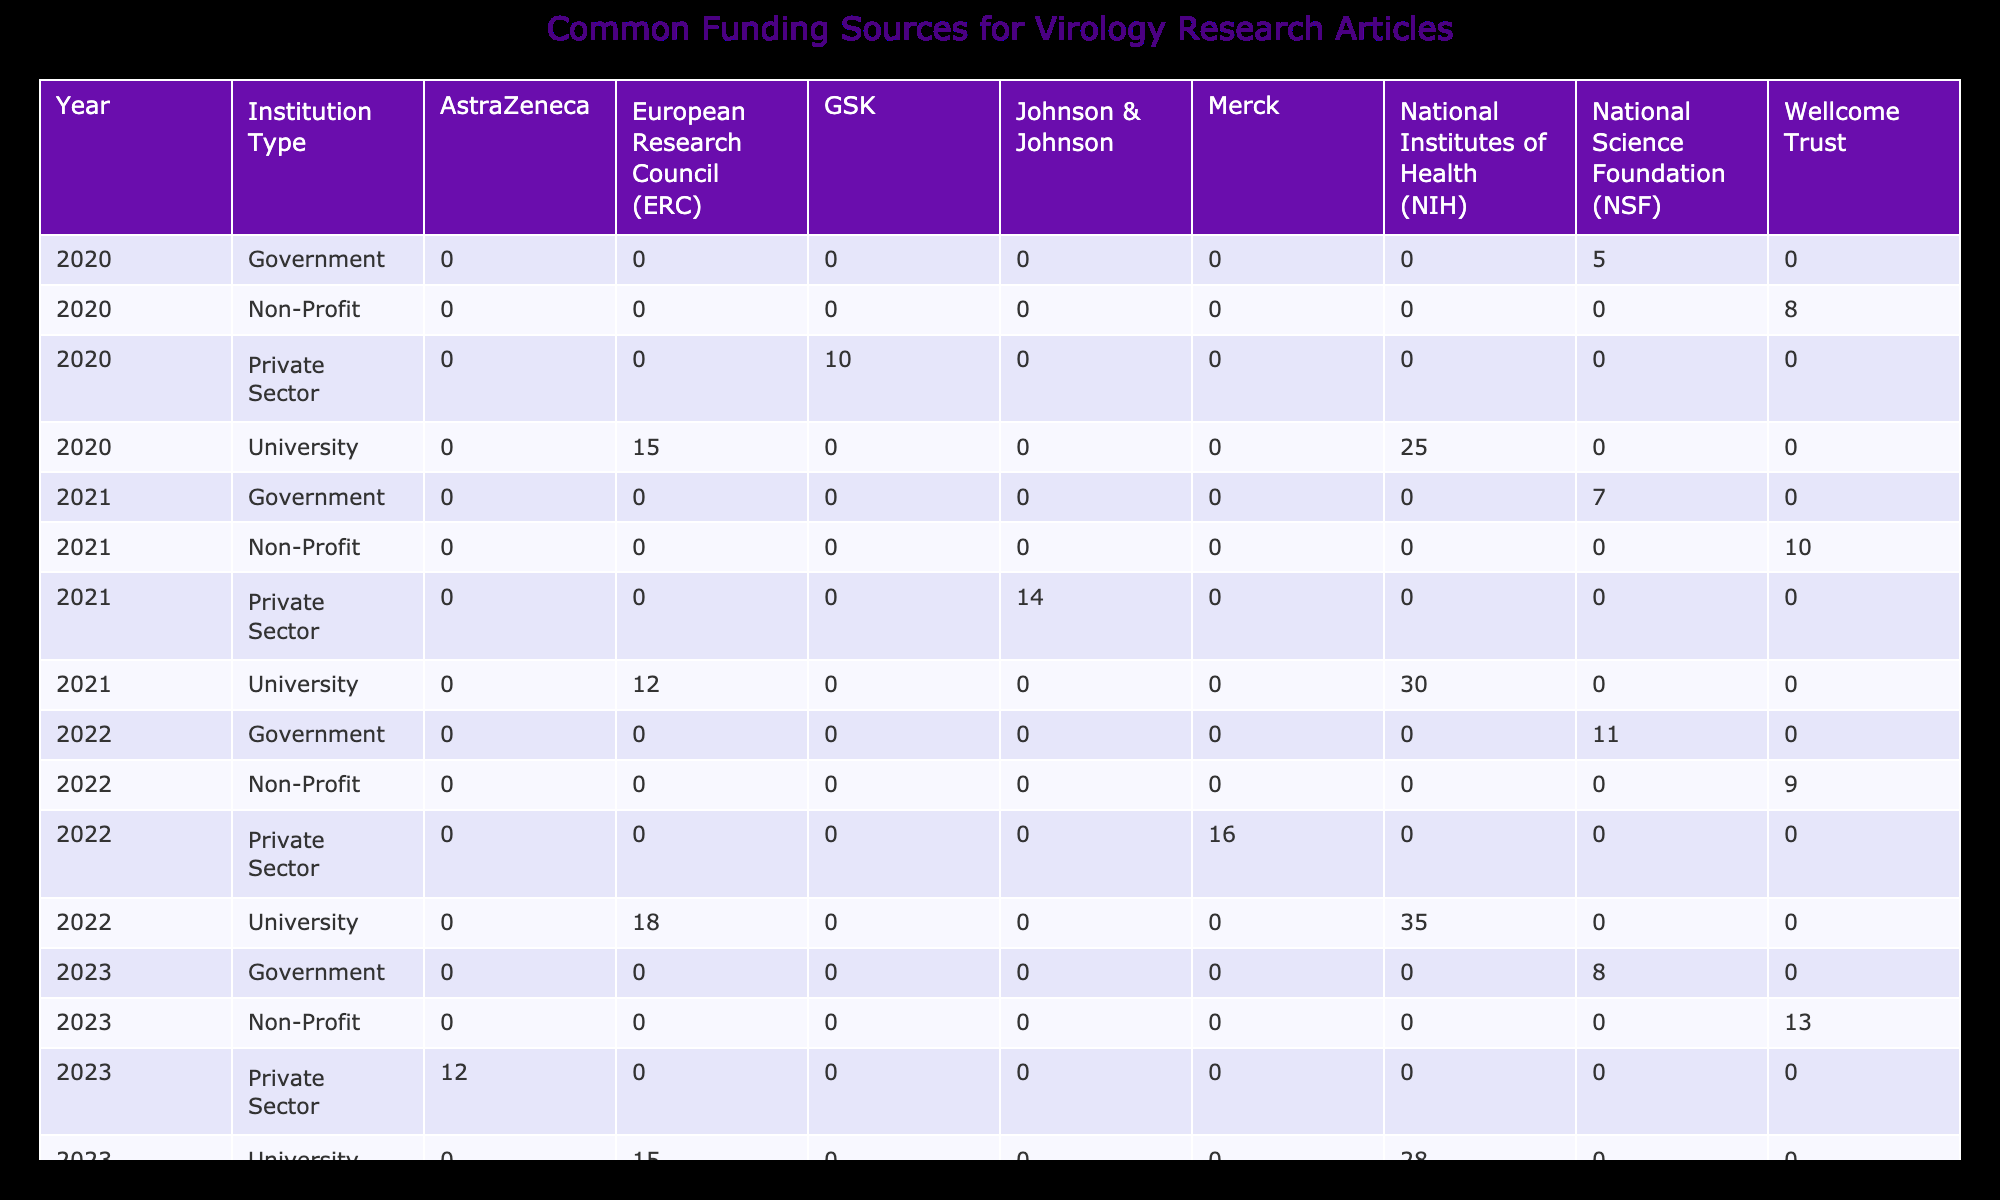What is the total number of research articles funded by the European Research Council in 2020? In 2020, the table shows that the European Research Council funded 15 research articles within universities. Since no other institution type is shown for this funding source in that year, the total remains 15.
Answer: 15 Which institution type had the highest number of articles funded by the National Institutes of Health in 2022? The table shows that in the year 2022, universities received 35 articles funded by the National Institutes of Health, while there are no entries for other institution types for the same funding source. Thus, universities had the highest count.
Answer: University What is the average number of research articles funded by the Wellcome Trust across all years? Summing articles funded by the Wellcome Trust gives us (8 + 10 + 9 + 13) = 40 articles across the four years (2020 to 2023). To find the average, divide this by the number of years (4): 40/4 = 10.
Answer: 10 Did the number of research articles funded by GSK increase from 2020 to 2023? In 2020, GSK funded 10 research articles, while in 2023, there were no articles funded by GSK listed in the table. Thus, it can be concluded that funding from GSK did not increase.
Answer: No Which funding source had the lowest total number of research articles published in 2021? For 2021, the funding sources are NIH (30), ERC (12), Johnson & Johnson (14), NSF (7), and Wellcome Trust (10). The NSF had the lowest at 7 articles.
Answer: National Science Foundation (NSF) What is the difference in the number of research articles funded by the National Science Foundation (NSF) between 2020 and 2023? In 2020, NSF funded 5 articles, while in 2023 it funded 8 articles. The difference is computed as 8 - 5 = 3.
Answer: 3 Was there any funding from AstraZeneca in 2022? According to the data, there is no entry for AstraZeneca for any year in the table, which implies that no funding was reported for 2022.
Answer: No What is the trend of articles funded by the European Research Council (ERC) from 2020 to 2022? Looking at the figures: in 2020 there were 15 articles, in 2021 there were 12 articles, and in 2022 the figure increased to 18. Thus, the trend fluctuated, decreasing in 2021 before increasing again in 2022.
Answer: Fluctuating 